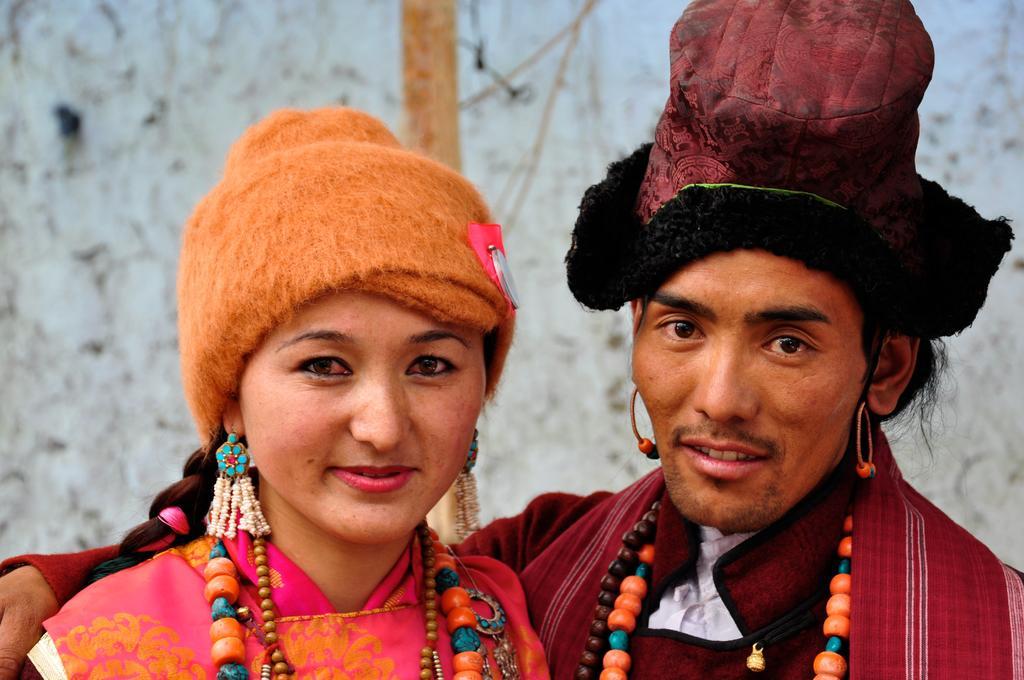Can you describe this image briefly? In this image, we can see a woman and man smiling. A man holding a woman. In the background, there is a blur view. 